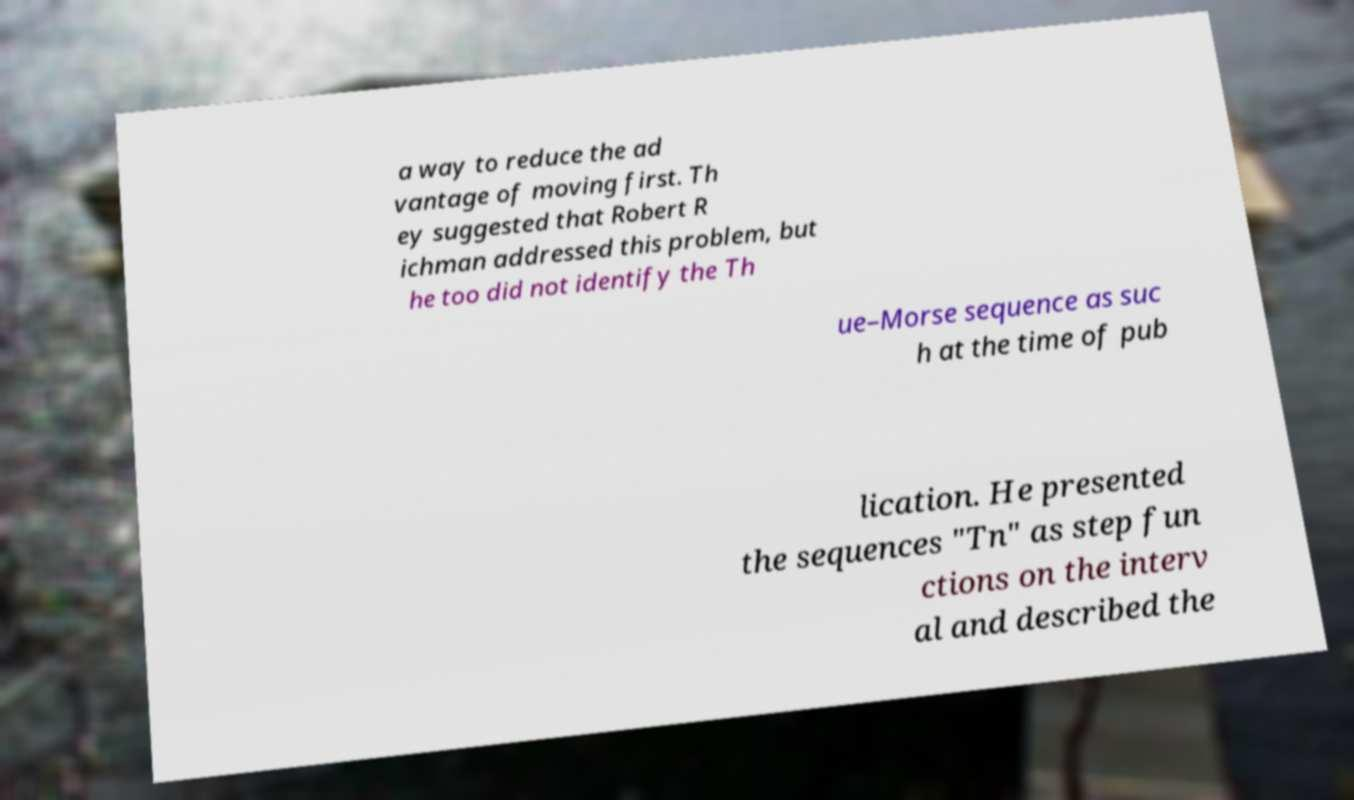For documentation purposes, I need the text within this image transcribed. Could you provide that? a way to reduce the ad vantage of moving first. Th ey suggested that Robert R ichman addressed this problem, but he too did not identify the Th ue–Morse sequence as suc h at the time of pub lication. He presented the sequences "Tn" as step fun ctions on the interv al and described the 